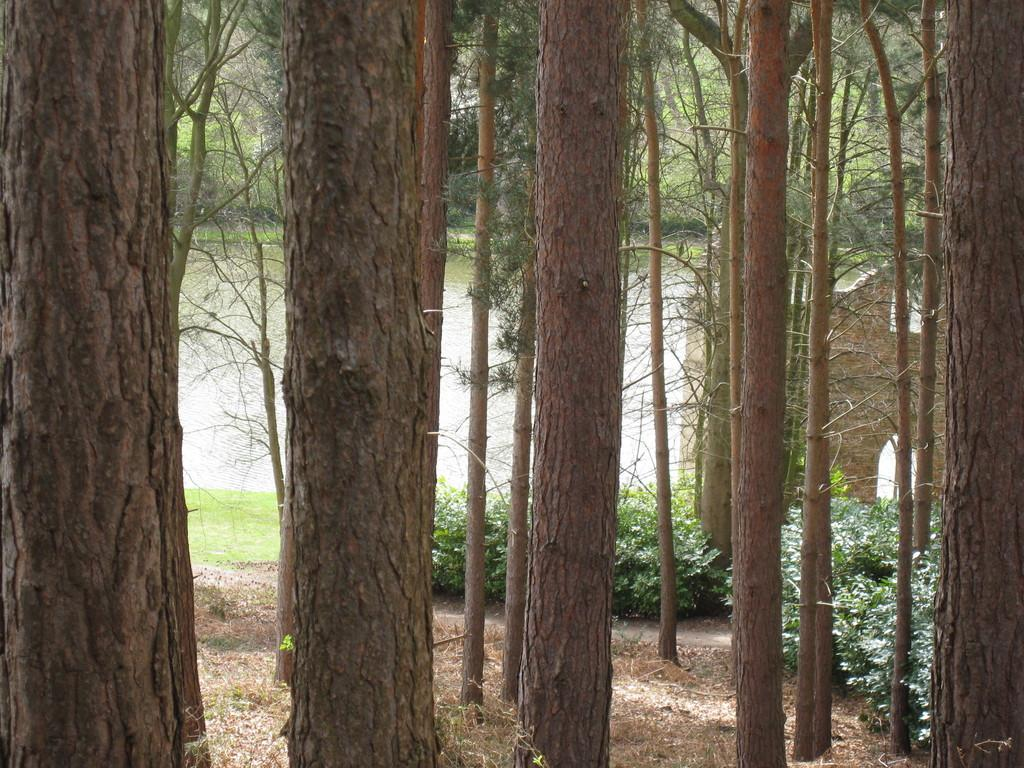What type of vegetation can be seen in the image? There are trees and plants in the image. What natural feature is present in the image? There is a river in the image. What type of sweater is being worn by the river in the image? There is no sweater present in the image, as the river is a natural feature and not a person or object that can wear clothing. 